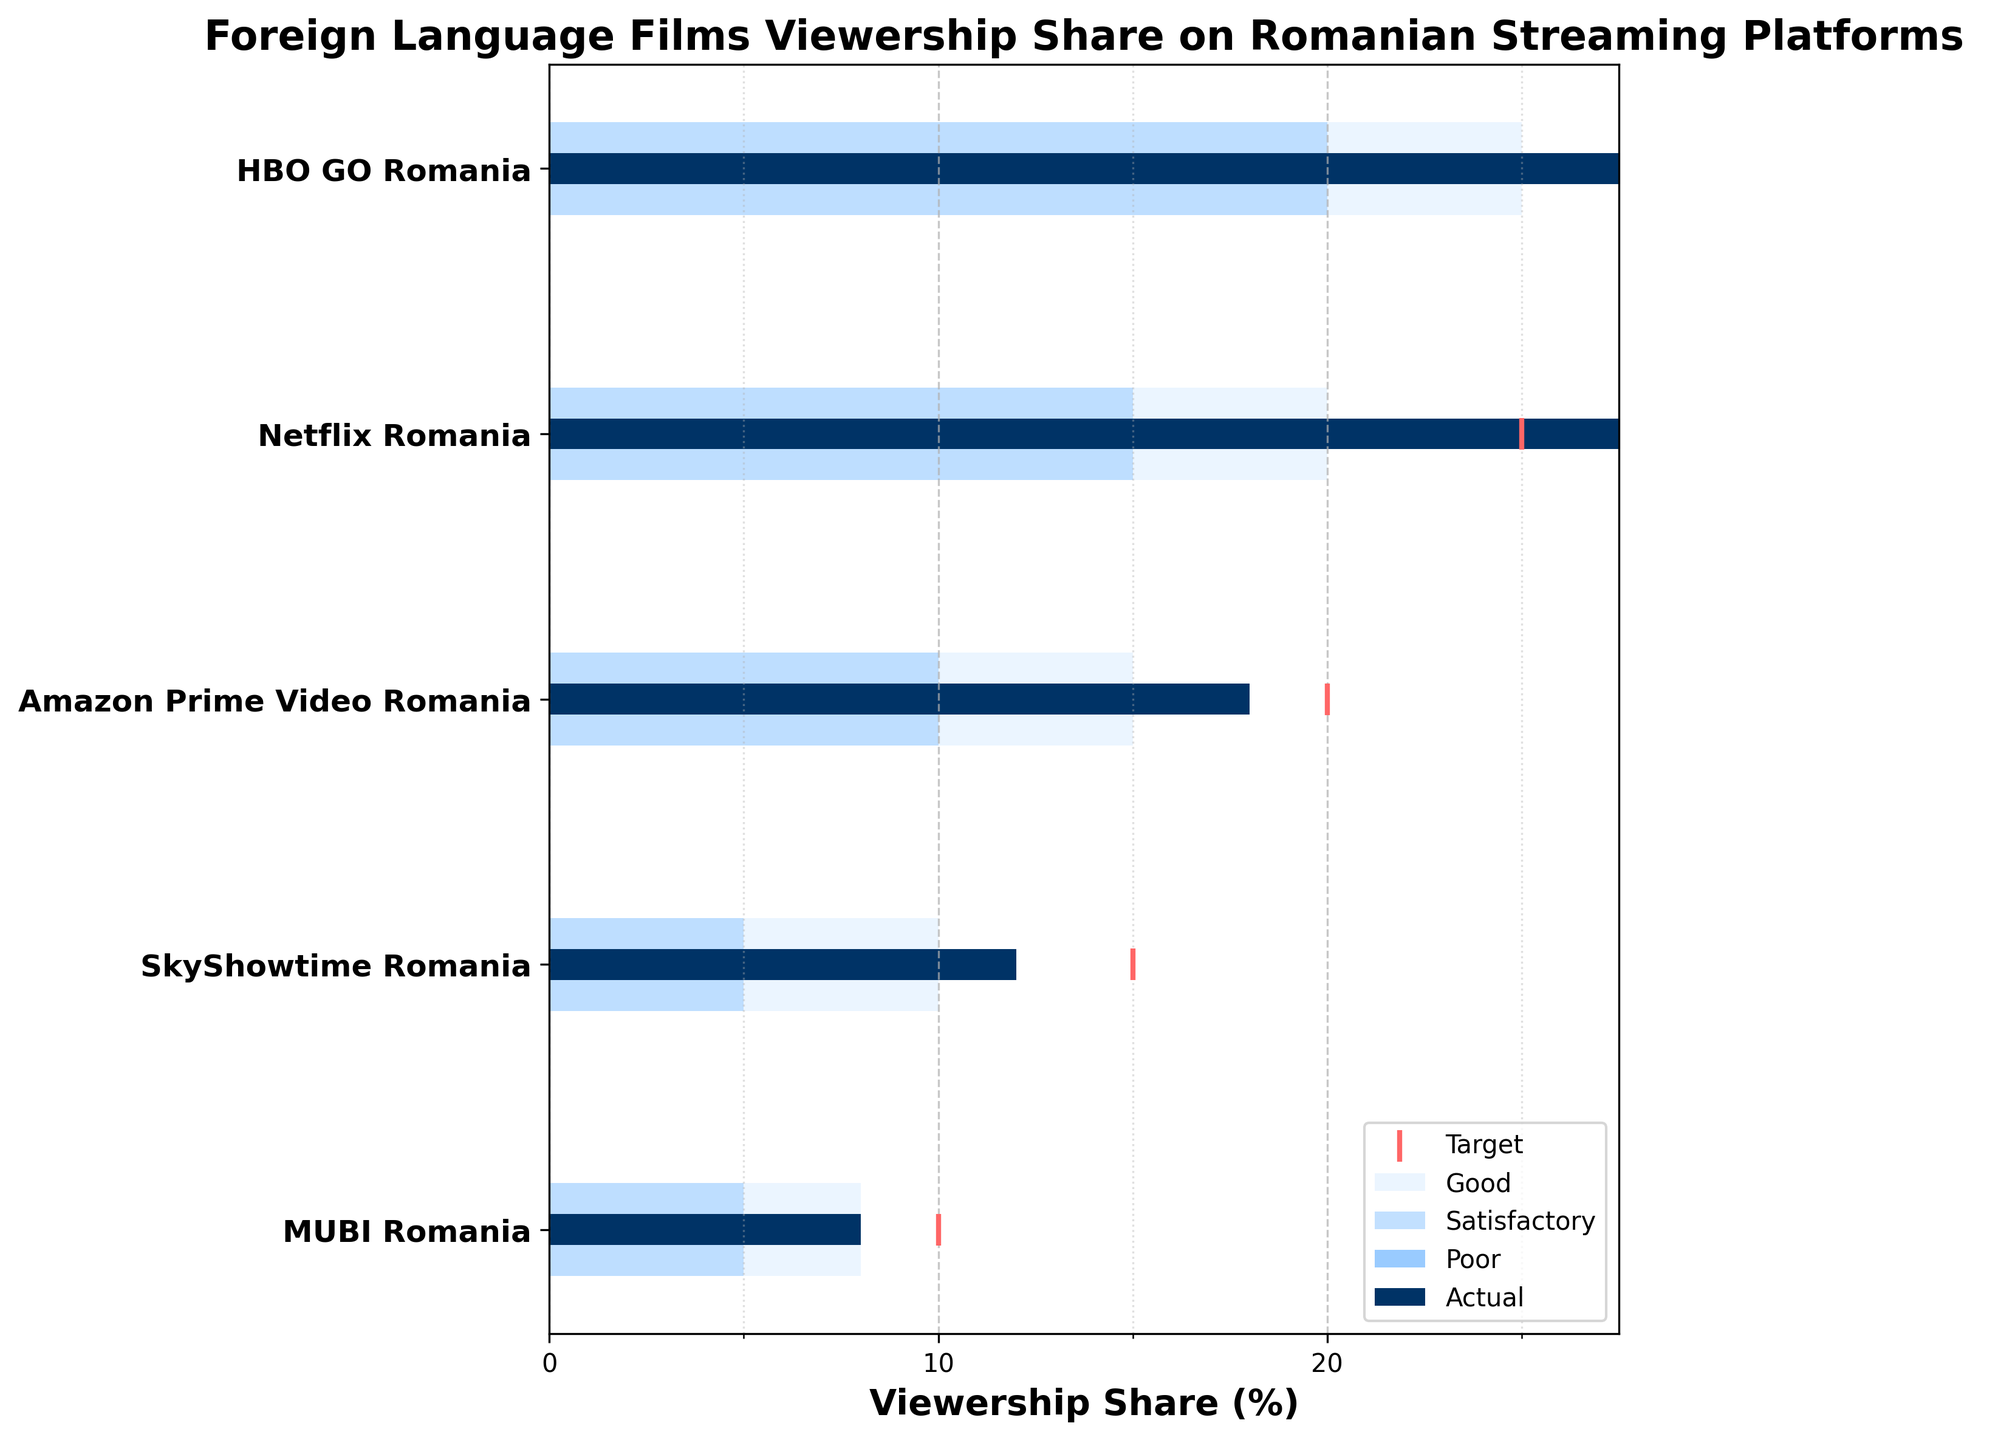How many streaming platforms are analyzed in the figure? Count the number of rows for the different streaming services shown on the y-axis.
Answer: 5 What is the title of the figure? The title can be seen at the top of the figure.
Answer: Foreign Language Films Viewership Share on Romanian Streaming Platforms Which platform has the highest actual viewership for foreign language films? Examine the bar lengths and labels for `Actual` values, and identify the platform with the longest bar.
Answer: HBO GO Romania What is the combined target viewership share for Netflix Romania and HBO GO Romania? Add the target values for Netflix Romania (25) and HBO GO Romania (30). 25 + 30 = 55.
Answer: 55 How does Amazon Prime Video Romania's actual viewership compare to its target? Compare Amazon Prime Video Romania's actual viewership (18) to its target (20).
Answer: Lower How many platforms have an actual viewership share greater than their target? Identify platforms where the `Actual` bar is longer than the target marker.
Answer: 2 Between Netflix Romania and SkyShowtime Romania, which has a higher actual viewership for foreign language films? Compare the `Actual` values of Netflix Romania (28) and SkyShowtime Romania (12).
Answer: Netflix Romania Which platforms have their actual viewership within the satisfactory range? Check if the `Actual` values fall within the range marked as `Satisfactory` for each platform.
Answer: HBO GO Romania, Netflix Romania If the target for Amazon Prime Video Romania were achieved, where would it fall within the performance ranges? Compare the target value (20) with the ranges (Poor, Satisfactory, Good). 20 falls within the `Good` range (10-15).
Answer: Good What is the difference between HBO GO Romania's actual viewership and MUBI Romania's actual viewership? Subtract MUBI Romania's actual viewership (8) from HBO GO Romania's actual viewership (35). 35 - 8 = 27.
Answer: 27 